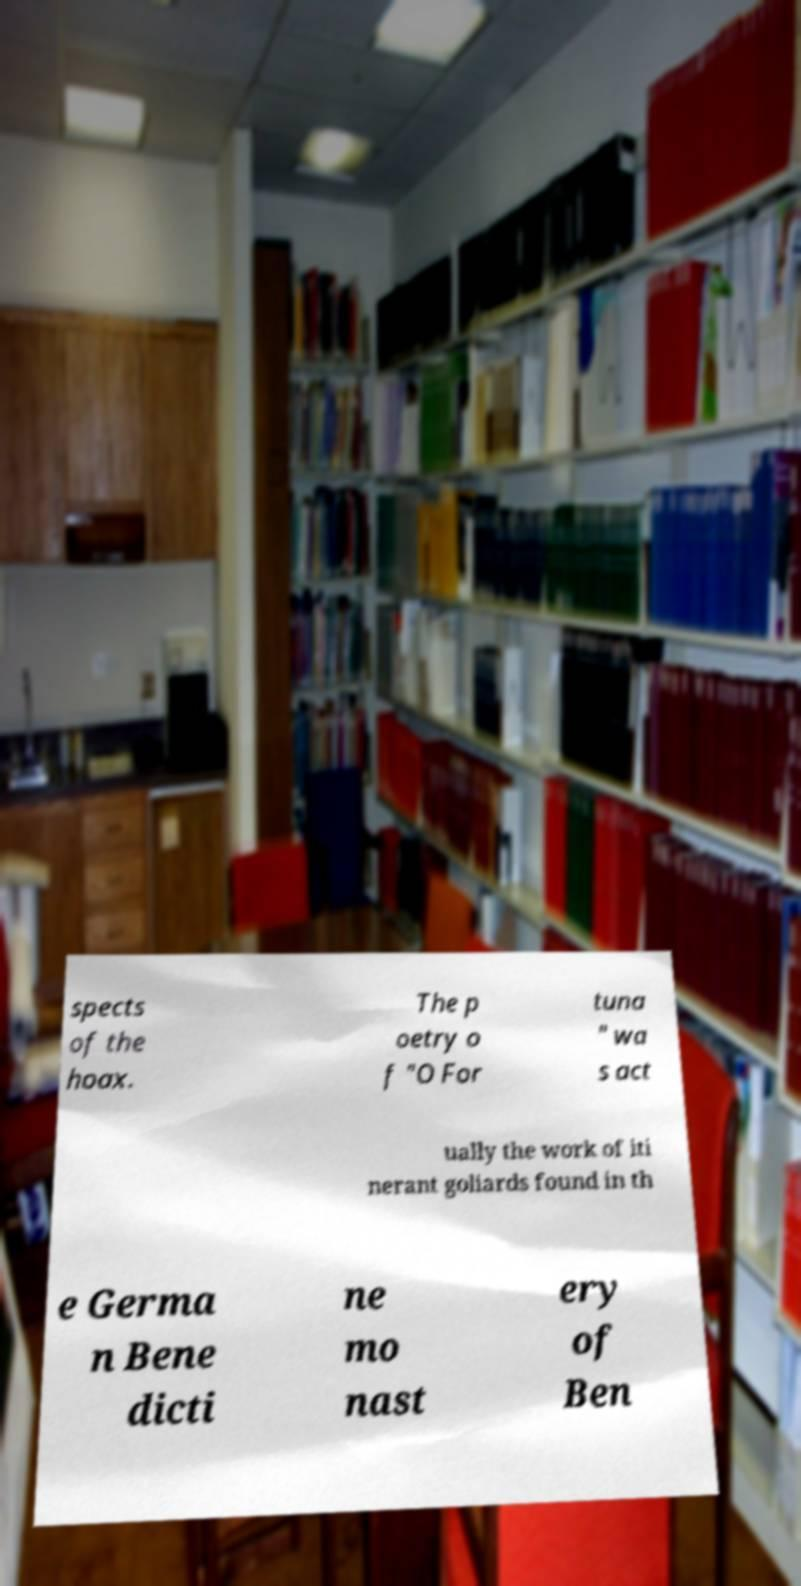I need the written content from this picture converted into text. Can you do that? spects of the hoax. The p oetry o f "O For tuna " wa s act ually the work of iti nerant goliards found in th e Germa n Bene dicti ne mo nast ery of Ben 